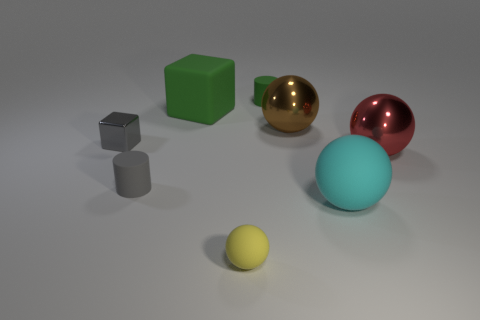What number of objects are tiny green things or big matte objects?
Your answer should be compact. 3. There is a green object on the right side of the rubber sphere that is left of the brown metallic thing; what is its size?
Ensure brevity in your answer.  Small. The yellow matte ball is what size?
Offer a terse response. Small. There is a small object that is in front of the large red sphere and right of the rubber block; what shape is it?
Make the answer very short. Sphere. What color is the big object that is the same shape as the small shiny thing?
Your response must be concise. Green. What number of objects are tiny metallic blocks that are behind the small sphere or cylinders that are in front of the large brown shiny thing?
Your answer should be very brief. 2. There is a big brown thing; what shape is it?
Give a very brief answer. Sphere. What shape is the thing that is the same color as the matte cube?
Offer a very short reply. Cylinder. What number of cubes are made of the same material as the yellow sphere?
Give a very brief answer. 1. What color is the tiny ball?
Offer a terse response. Yellow. 